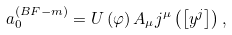<formula> <loc_0><loc_0><loc_500><loc_500>a _ { 0 } ^ { ( B F - m ) } = U \left ( \varphi \right ) A _ { \mu } j ^ { \mu } \left ( \left [ y ^ { j } \right ] \right ) ,</formula> 